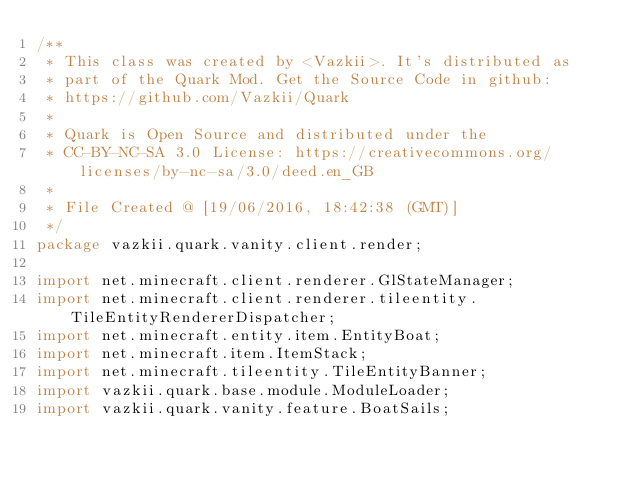<code> <loc_0><loc_0><loc_500><loc_500><_Java_>/**
 * This class was created by <Vazkii>. It's distributed as
 * part of the Quark Mod. Get the Source Code in github:
 * https://github.com/Vazkii/Quark
 *
 * Quark is Open Source and distributed under the
 * CC-BY-NC-SA 3.0 License: https://creativecommons.org/licenses/by-nc-sa/3.0/deed.en_GB
 *
 * File Created @ [19/06/2016, 18:42:38 (GMT)]
 */
package vazkii.quark.vanity.client.render;

import net.minecraft.client.renderer.GlStateManager;
import net.minecraft.client.renderer.tileentity.TileEntityRendererDispatcher;
import net.minecraft.entity.item.EntityBoat;
import net.minecraft.item.ItemStack;
import net.minecraft.tileentity.TileEntityBanner;
import vazkii.quark.base.module.ModuleLoader;
import vazkii.quark.vanity.feature.BoatSails;
</code> 